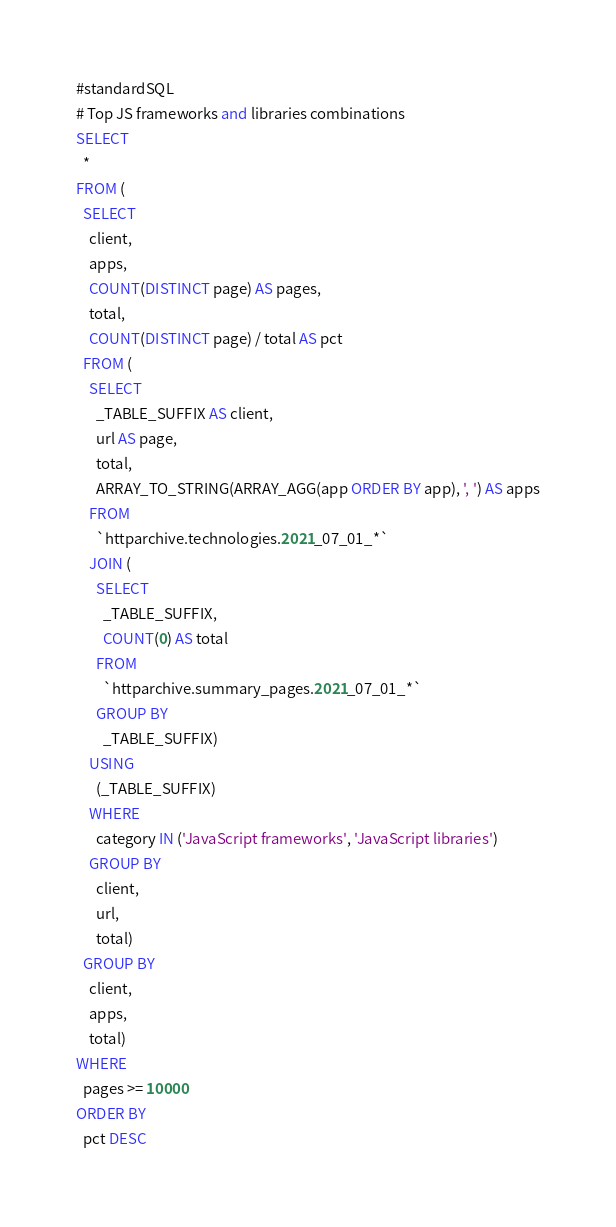<code> <loc_0><loc_0><loc_500><loc_500><_SQL_>#standardSQL
# Top JS frameworks and libraries combinations
SELECT
  *
FROM (
  SELECT
    client,
    apps,
    COUNT(DISTINCT page) AS pages,
    total,
    COUNT(DISTINCT page) / total AS pct
  FROM (
    SELECT
      _TABLE_SUFFIX AS client,
      url AS page,
      total,
      ARRAY_TO_STRING(ARRAY_AGG(app ORDER BY app), ', ') AS apps
    FROM
      `httparchive.technologies.2021_07_01_*`
    JOIN (
      SELECT
        _TABLE_SUFFIX,
        COUNT(0) AS total
      FROM
        `httparchive.summary_pages.2021_07_01_*`
      GROUP BY
        _TABLE_SUFFIX)
    USING
      (_TABLE_SUFFIX)
    WHERE
      category IN ('JavaScript frameworks', 'JavaScript libraries')
    GROUP BY
      client,
      url,
      total)
  GROUP BY
    client,
    apps,
    total)
WHERE
  pages >= 10000
ORDER BY
  pct DESC
</code> 